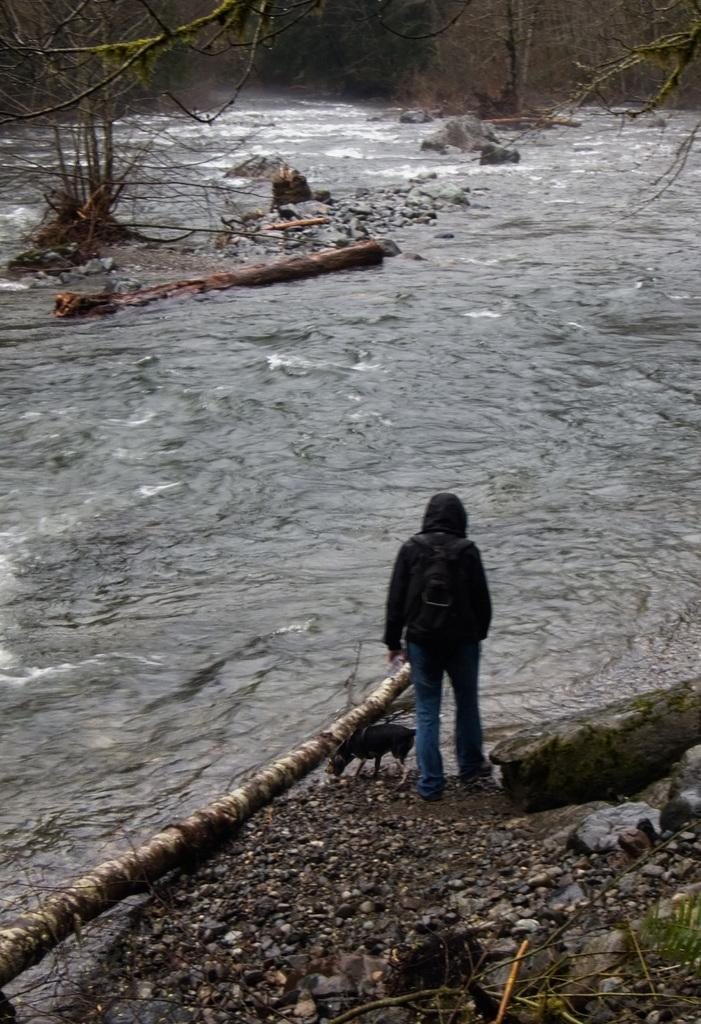Who is present at the bottom of the image? There is a person at the bottom of the image. What is the person wearing? The person is wearing a jacket and trousers. What is the person carrying? The person is carrying a bag. What type of animal can be seen in the image? There is an animal in the image. What is present on the ground in the image? There are stones in the image. What type of terrain is visible in the image? There is land visible in the image. What can be seen in the background of the image? There are trees, waves, and water visible in the background of the image. What word is written on the person's shoes in the image? There is no mention of shoes in the image, so it is not possible to determine if any words are written on them. 